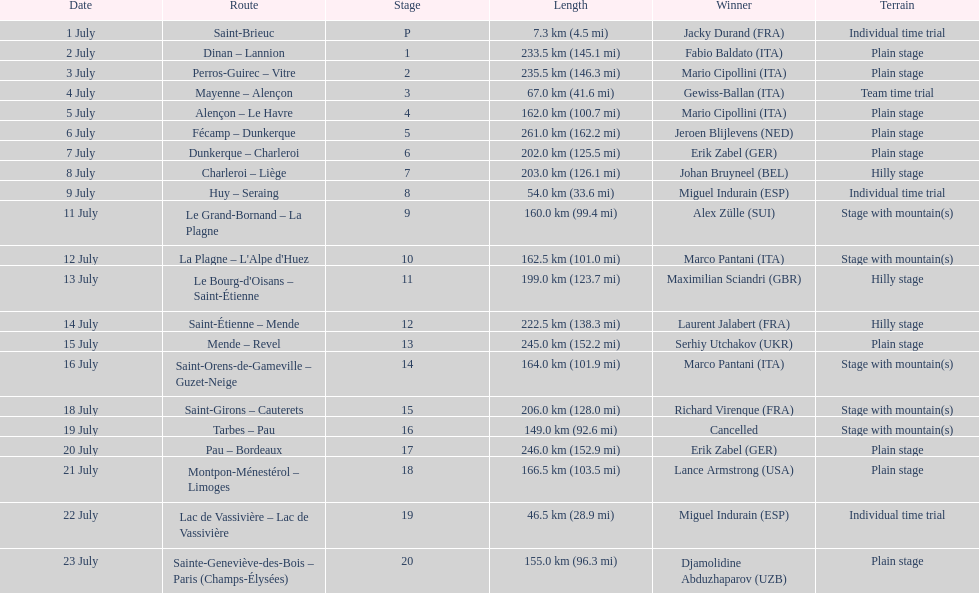Which routes were at least 100 km? Dinan - Lannion, Perros-Guirec - Vitre, Alençon - Le Havre, Fécamp - Dunkerque, Dunkerque - Charleroi, Charleroi - Liège, Le Grand-Bornand - La Plagne, La Plagne - L'Alpe d'Huez, Le Bourg-d'Oisans - Saint-Étienne, Saint-Étienne - Mende, Mende - Revel, Saint-Orens-de-Gameville - Guzet-Neige, Saint-Girons - Cauterets, Tarbes - Pau, Pau - Bordeaux, Montpon-Ménestérol - Limoges, Sainte-Geneviève-des-Bois - Paris (Champs-Élysées). 